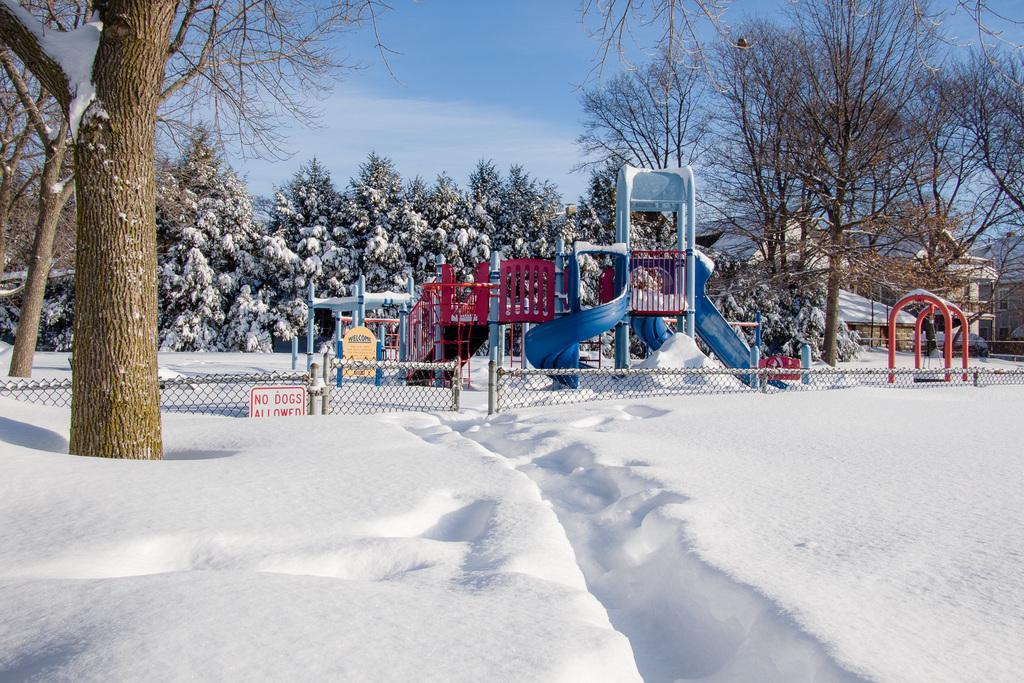How would you summarize this image in a sentence or two? There is snow in the foreground area of the image, there are slides, net boundary, trees, it seems like houses and the sky in the background. 